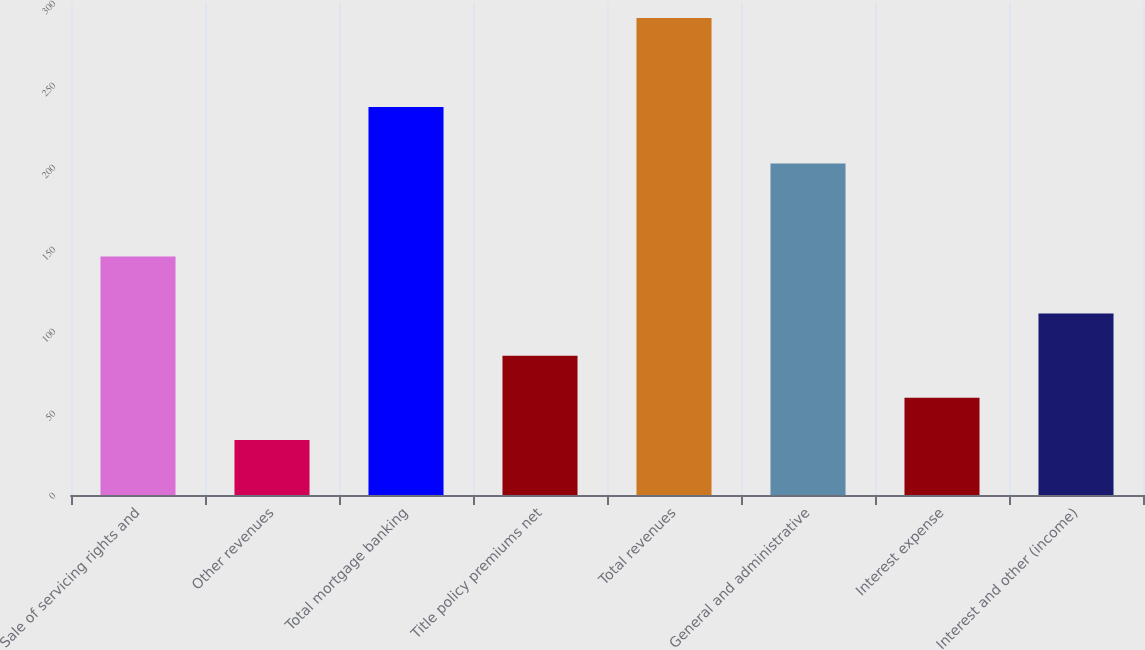Convert chart. <chart><loc_0><loc_0><loc_500><loc_500><bar_chart><fcel>Sale of servicing rights and<fcel>Other revenues<fcel>Total mortgage banking<fcel>Title policy premiums net<fcel>Total revenues<fcel>General and administrative<fcel>Interest expense<fcel>Interest and other (income)<nl><fcel>145.5<fcel>33.5<fcel>236.6<fcel>84.96<fcel>290.8<fcel>202.2<fcel>59.23<fcel>110.69<nl></chart> 